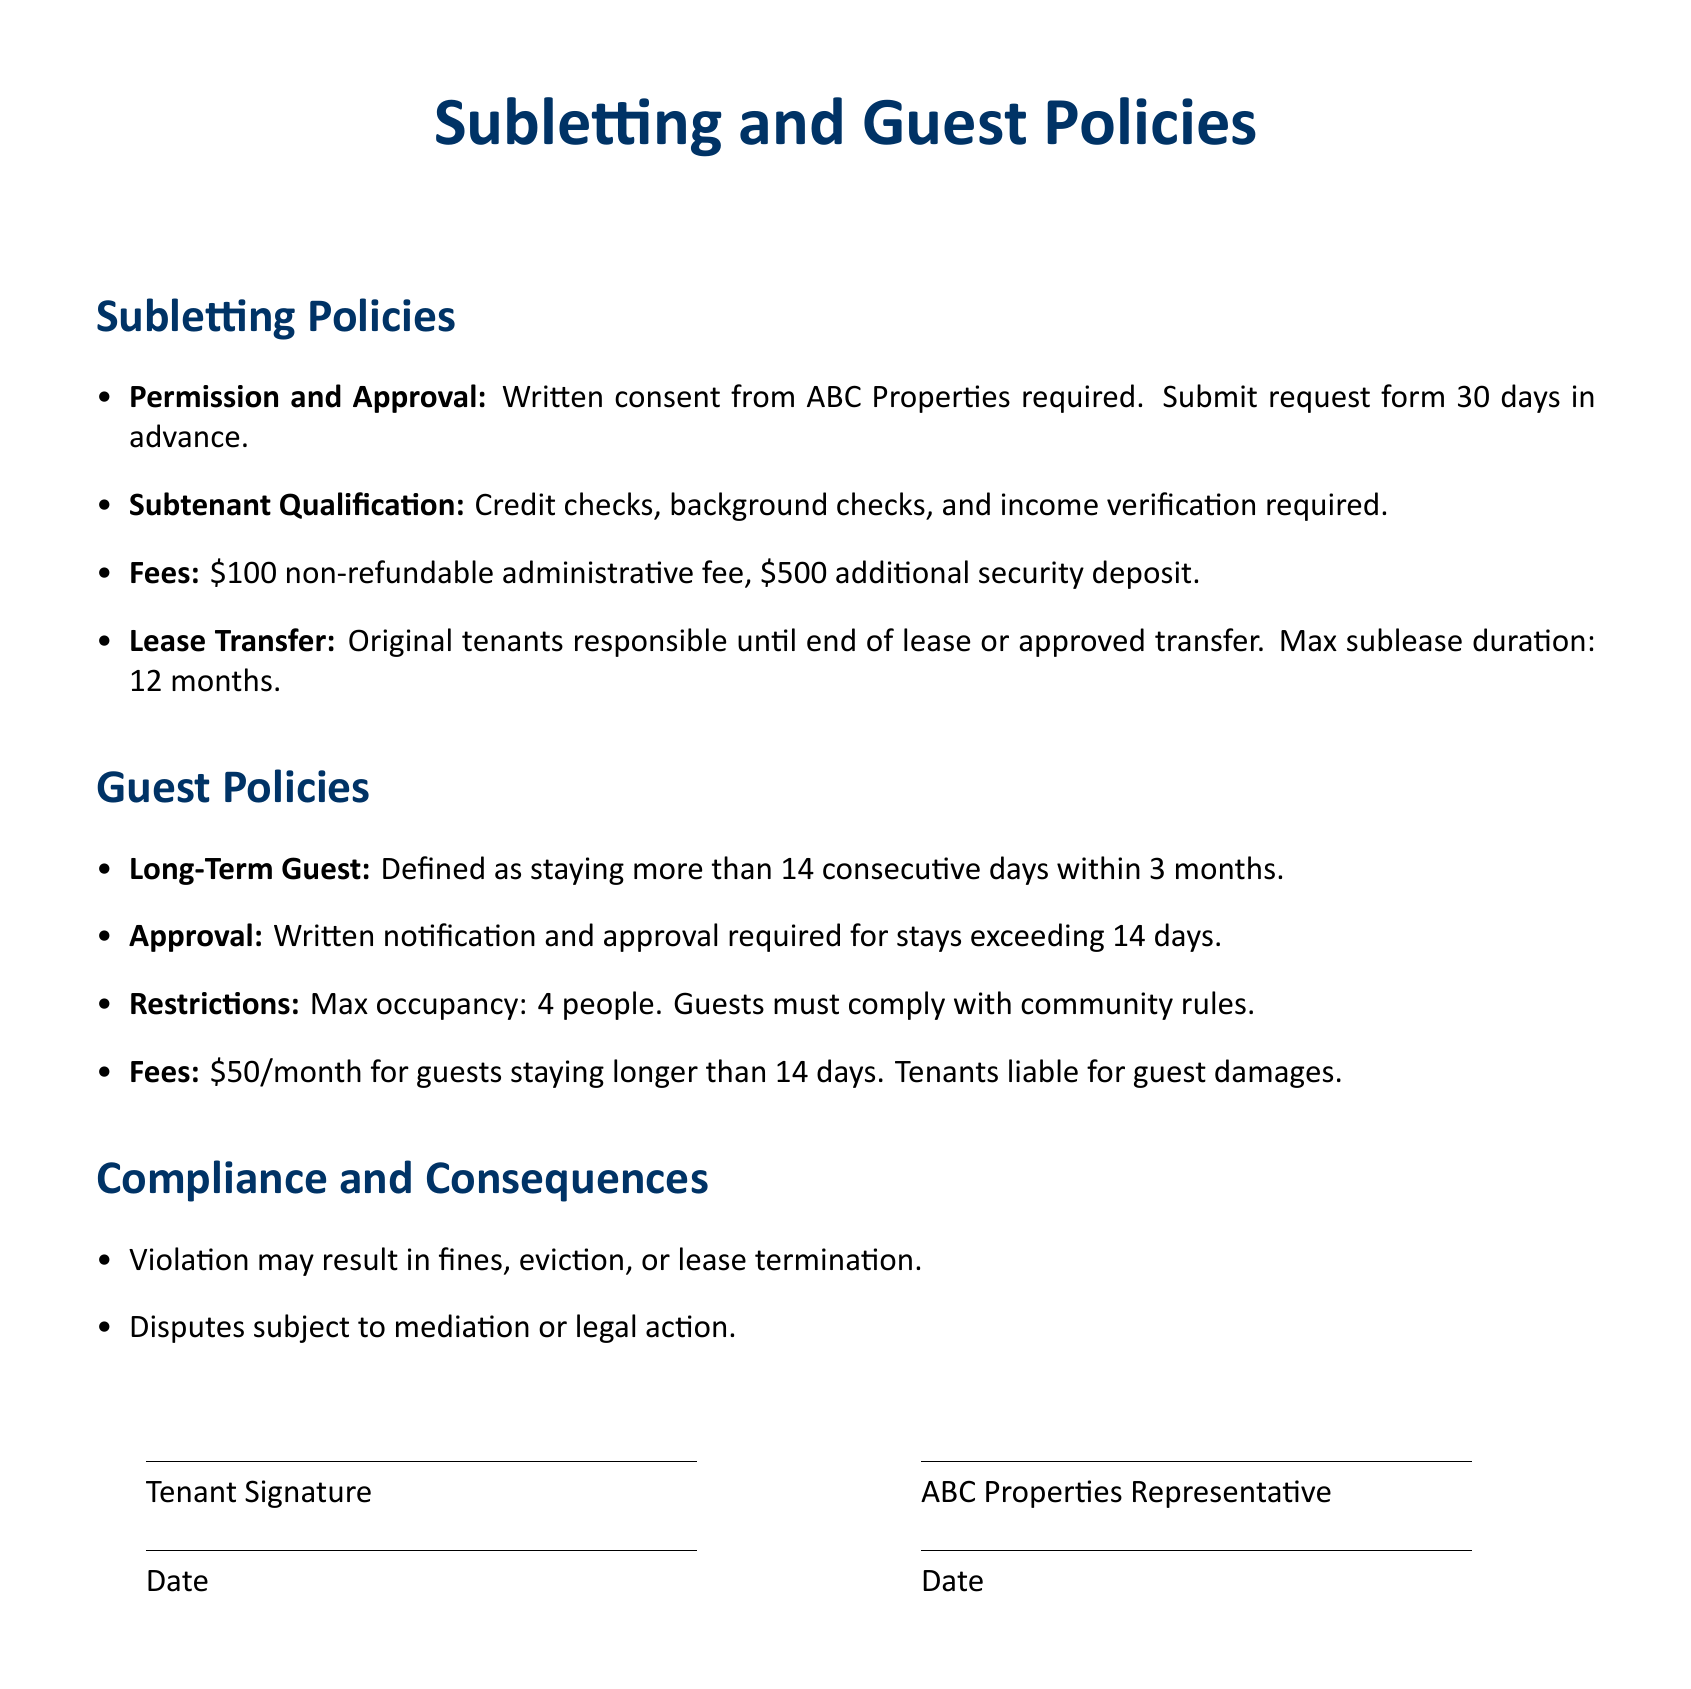What is required for subletting the apartment? A written consent from ABC Properties is required.
Answer: Written consent How long in advance must the subletting request be submitted? The request must be submitted 30 days in advance.
Answer: 30 days What is the non-refundable administrative fee for subletting? The document states a non-refundable administrative fee of $100.
Answer: $100 What is the maximum duration for a sublease? The lease allows a maximum sublease duration of 12 months.
Answer: 12 months How is a long-term guest defined? A long-term guest is defined as someone staying more than 14 consecutive days within 3 months.
Answer: More than 14 consecutive days What is the occupancy limit for guests? The maximum occupancy limit specified is 4 people.
Answer: 4 people What must tenants do if their guests cause damages? Tenants are liable for damages caused by their guests.
Answer: Liable for guest damages What fee applies for guests staying longer than 14 days? There is a $50 fee for guests staying longer than 14 days.
Answer: $50 What could be a consequence of violating the policies? Violations may result in fines, eviction, or lease termination.
Answer: Fines, eviction, or lease termination What type of approval is needed for a long-term guest? Written notification and approval are required for long-term guests.
Answer: Written notification and approval 